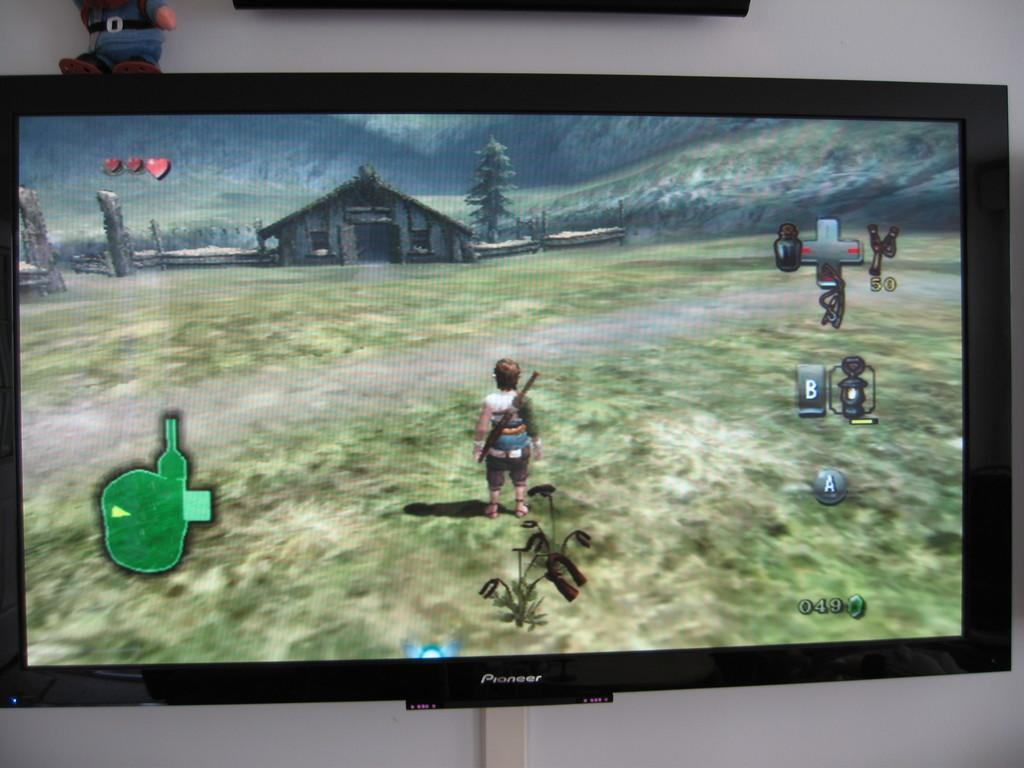<image>
Summarize the visual content of the image. A pioneer television is turned on with a game showing in the screen. 